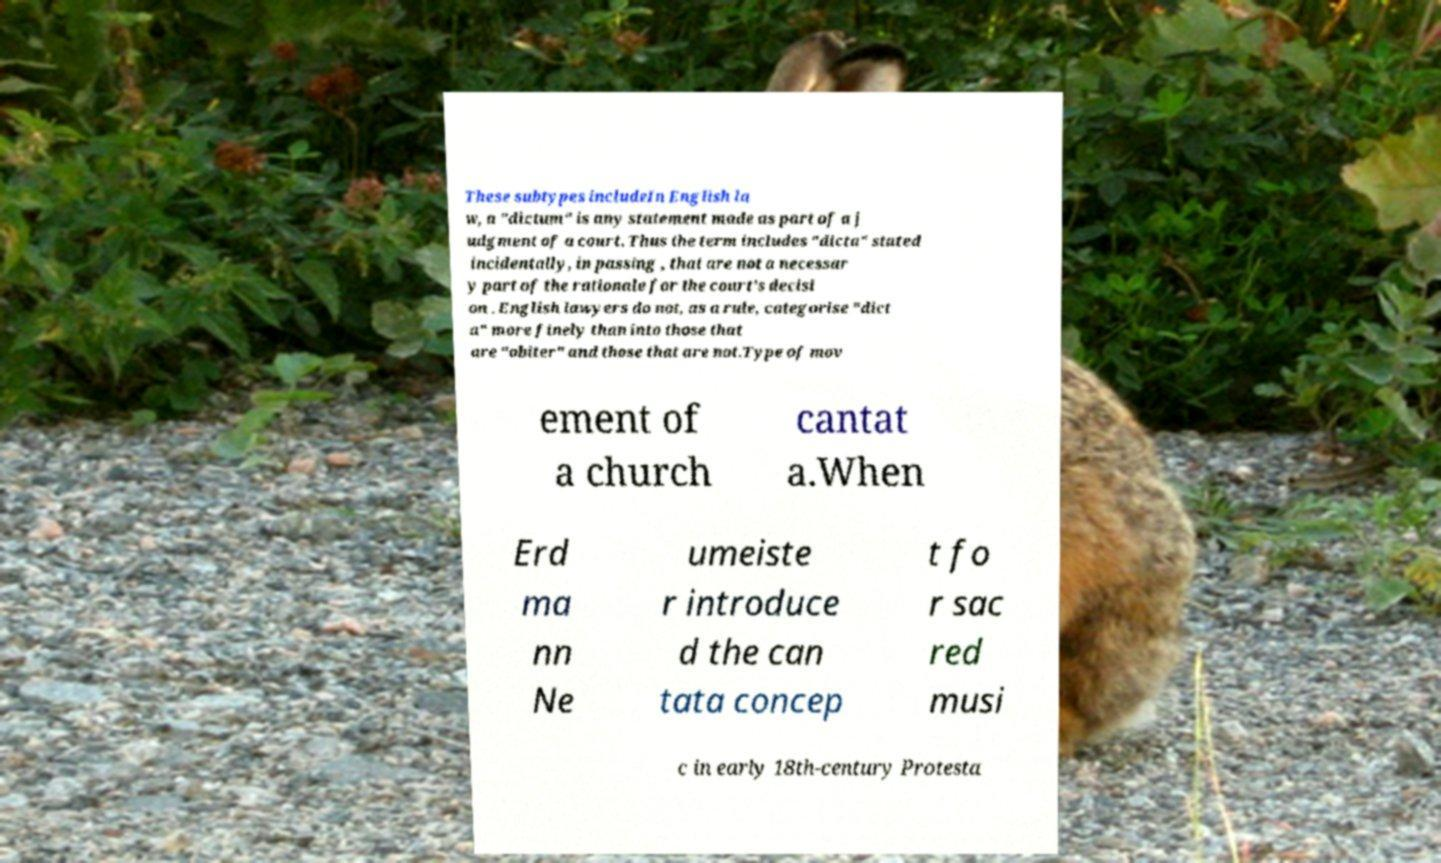There's text embedded in this image that I need extracted. Can you transcribe it verbatim? These subtypes includeIn English la w, a "dictum" is any statement made as part of a j udgment of a court. Thus the term includes "dicta" stated incidentally, in passing , that are not a necessar y part of the rationale for the court's decisi on . English lawyers do not, as a rule, categorise "dict a" more finely than into those that are "obiter" and those that are not.Type of mov ement of a church cantat a.When Erd ma nn Ne umeiste r introduce d the can tata concep t fo r sac red musi c in early 18th-century Protesta 